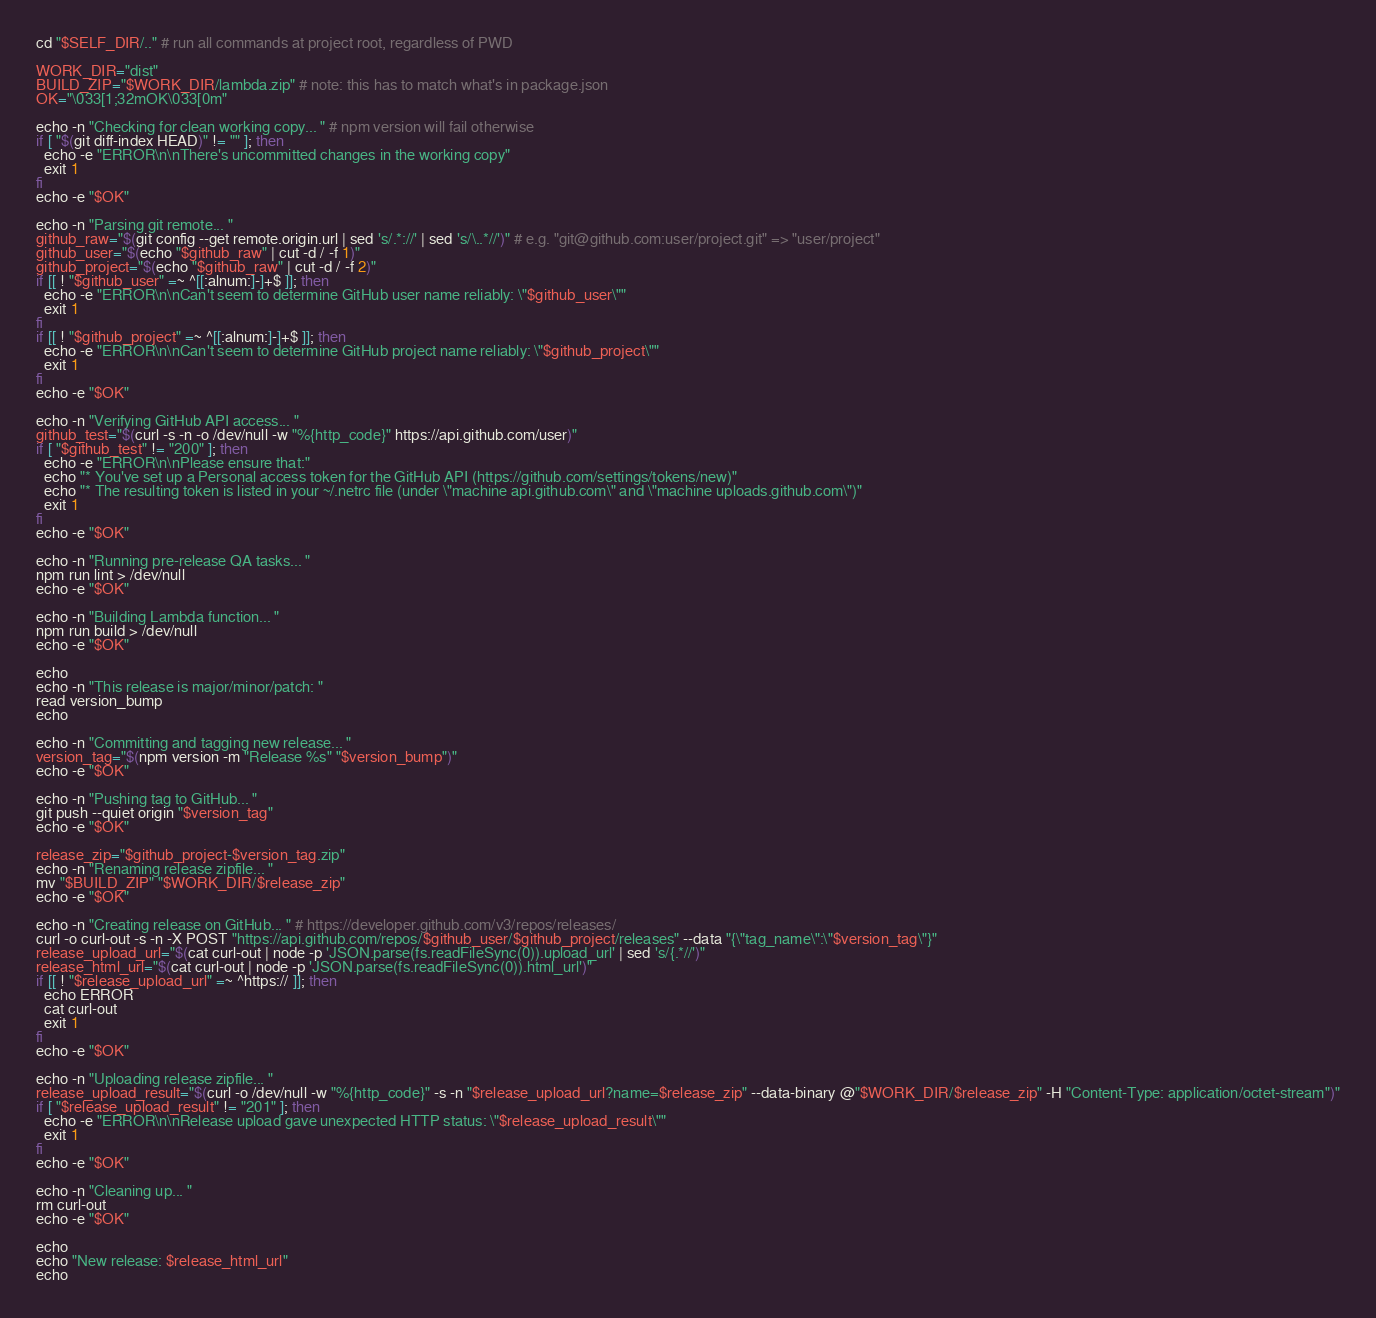<code> <loc_0><loc_0><loc_500><loc_500><_Bash_>cd "$SELF_DIR/.." # run all commands at project root, regardless of PWD

WORK_DIR="dist"
BUILD_ZIP="$WORK_DIR/lambda.zip" # note: this has to match what's in package.json
OK="\033[1;32mOK\033[0m"

echo -n "Checking for clean working copy... " # npm version will fail otherwise
if [ "$(git diff-index HEAD)" != "" ]; then
  echo -e "ERROR\n\nThere's uncommitted changes in the working copy"
  exit 1
fi
echo -e "$OK"

echo -n "Parsing git remote... "
github_raw="$(git config --get remote.origin.url | sed 's/.*://' | sed 's/\..*//')" # e.g. "git@github.com:user/project.git" => "user/project"
github_user="$(echo "$github_raw" | cut -d / -f 1)"
github_project="$(echo "$github_raw" | cut -d / -f 2)"
if [[ ! "$github_user" =~ ^[[:alnum:]-]+$ ]]; then
  echo -e "ERROR\n\nCan't seem to determine GitHub user name reliably: \"$github_user\""
  exit 1
fi
if [[ ! "$github_project" =~ ^[[:alnum:]-]+$ ]]; then
  echo -e "ERROR\n\nCan't seem to determine GitHub project name reliably: \"$github_project\""
  exit 1
fi
echo -e "$OK"

echo -n "Verifying GitHub API access... "
github_test="$(curl -s -n -o /dev/null -w "%{http_code}" https://api.github.com/user)"
if [ "$github_test" != "200" ]; then
  echo -e "ERROR\n\nPlease ensure that:"
  echo "* You've set up a Personal access token for the GitHub API (https://github.com/settings/tokens/new)"
  echo "* The resulting token is listed in your ~/.netrc file (under \"machine api.github.com\" and \"machine uploads.github.com\")"
  exit 1
fi
echo -e "$OK"

echo -n "Running pre-release QA tasks... "
npm run lint > /dev/null
echo -e "$OK"

echo -n "Building Lambda function... "
npm run build > /dev/null
echo -e "$OK"

echo
echo -n "This release is major/minor/patch: "
read version_bump
echo

echo -n "Committing and tagging new release... "
version_tag="$(npm version -m "Release %s" "$version_bump")"
echo -e "$OK"

echo -n "Pushing tag to GitHub... "
git push --quiet origin "$version_tag"
echo -e "$OK"

release_zip="$github_project-$version_tag.zip"
echo -n "Renaming release zipfile... "
mv "$BUILD_ZIP" "$WORK_DIR/$release_zip"
echo -e "$OK"

echo -n "Creating release on GitHub... " # https://developer.github.com/v3/repos/releases/
curl -o curl-out -s -n -X POST "https://api.github.com/repos/$github_user/$github_project/releases" --data "{\"tag_name\":\"$version_tag\"}"
release_upload_url="$(cat curl-out | node -p 'JSON.parse(fs.readFileSync(0)).upload_url' | sed 's/{.*//')"
release_html_url="$(cat curl-out | node -p 'JSON.parse(fs.readFileSync(0)).html_url')"
if [[ ! "$release_upload_url" =~ ^https:// ]]; then
  echo ERROR
  cat curl-out
  exit 1
fi
echo -e "$OK"

echo -n "Uploading release zipfile... "
release_upload_result="$(curl -o /dev/null -w "%{http_code}" -s -n "$release_upload_url?name=$release_zip" --data-binary @"$WORK_DIR/$release_zip" -H "Content-Type: application/octet-stream")"
if [ "$release_upload_result" != "201" ]; then
  echo -e "ERROR\n\nRelease upload gave unexpected HTTP status: \"$release_upload_result\""
  exit 1
fi
echo -e "$OK"

echo -n "Cleaning up... "
rm curl-out
echo -e "$OK"

echo
echo "New release: $release_html_url"
echo
</code> 